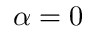<formula> <loc_0><loc_0><loc_500><loc_500>\alpha = 0</formula> 